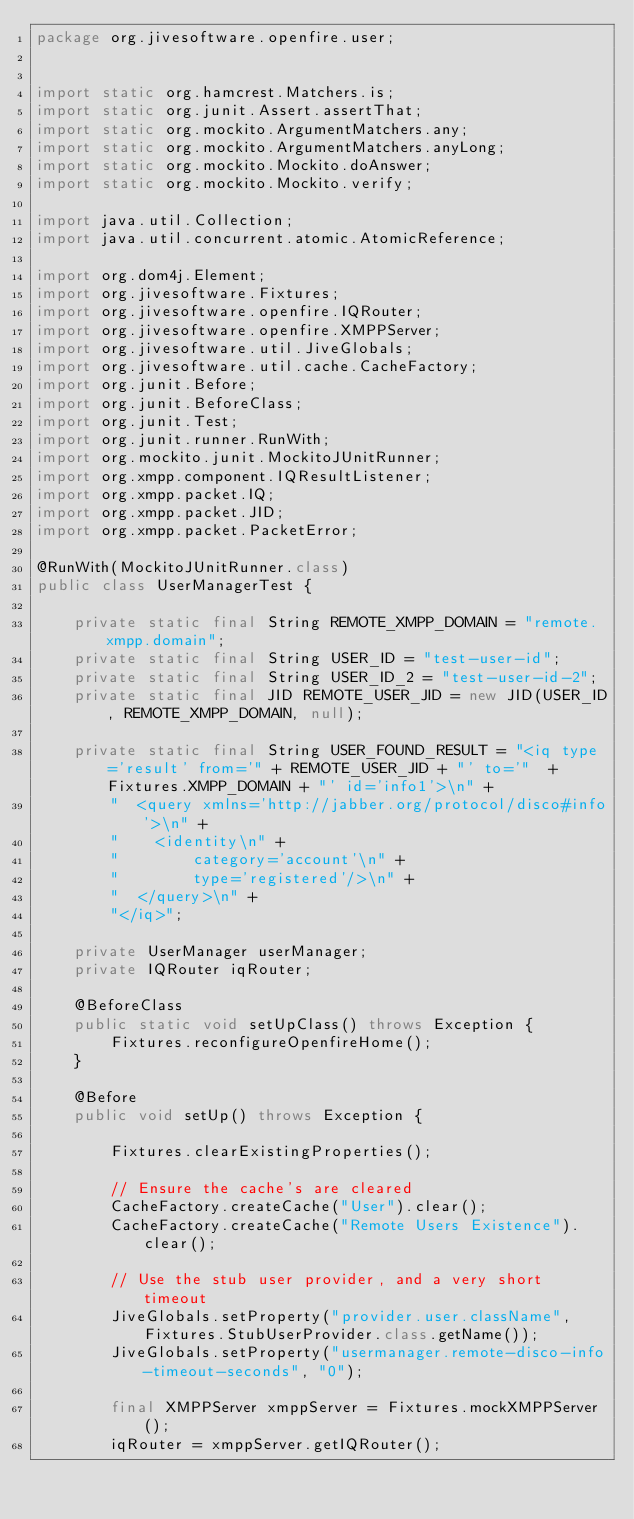Convert code to text. <code><loc_0><loc_0><loc_500><loc_500><_Java_>package org.jivesoftware.openfire.user;


import static org.hamcrest.Matchers.is;
import static org.junit.Assert.assertThat;
import static org.mockito.ArgumentMatchers.any;
import static org.mockito.ArgumentMatchers.anyLong;
import static org.mockito.Mockito.doAnswer;
import static org.mockito.Mockito.verify;

import java.util.Collection;
import java.util.concurrent.atomic.AtomicReference;

import org.dom4j.Element;
import org.jivesoftware.Fixtures;
import org.jivesoftware.openfire.IQRouter;
import org.jivesoftware.openfire.XMPPServer;
import org.jivesoftware.util.JiveGlobals;
import org.jivesoftware.util.cache.CacheFactory;
import org.junit.Before;
import org.junit.BeforeClass;
import org.junit.Test;
import org.junit.runner.RunWith;
import org.mockito.junit.MockitoJUnitRunner;
import org.xmpp.component.IQResultListener;
import org.xmpp.packet.IQ;
import org.xmpp.packet.JID;
import org.xmpp.packet.PacketError;

@RunWith(MockitoJUnitRunner.class)
public class UserManagerTest {

    private static final String REMOTE_XMPP_DOMAIN = "remote.xmpp.domain";
    private static final String USER_ID = "test-user-id";
    private static final String USER_ID_2 = "test-user-id-2";
    private static final JID REMOTE_USER_JID = new JID(USER_ID, REMOTE_XMPP_DOMAIN, null);

    private static final String USER_FOUND_RESULT = "<iq type='result' from='" + REMOTE_USER_JID + "' to='"  + Fixtures.XMPP_DOMAIN + "' id='info1'>\n" +
        "  <query xmlns='http://jabber.org/protocol/disco#info'>\n" +
        "    <identity\n" +
        "        category='account'\n" +
        "        type='registered'/>\n" +
        "  </query>\n" +
        "</iq>";

    private UserManager userManager;
    private IQRouter iqRouter;

    @BeforeClass
    public static void setUpClass() throws Exception {
        Fixtures.reconfigureOpenfireHome();
    }

    @Before
    public void setUp() throws Exception {

        Fixtures.clearExistingProperties();

        // Ensure the cache's are cleared
        CacheFactory.createCache("User").clear();
        CacheFactory.createCache("Remote Users Existence").clear();

        // Use the stub user provider, and a very short timeout
        JiveGlobals.setProperty("provider.user.className", Fixtures.StubUserProvider.class.getName());
        JiveGlobals.setProperty("usermanager.remote-disco-info-timeout-seconds", "0");

        final XMPPServer xmppServer = Fixtures.mockXMPPServer();
        iqRouter = xmppServer.getIQRouter();
</code> 